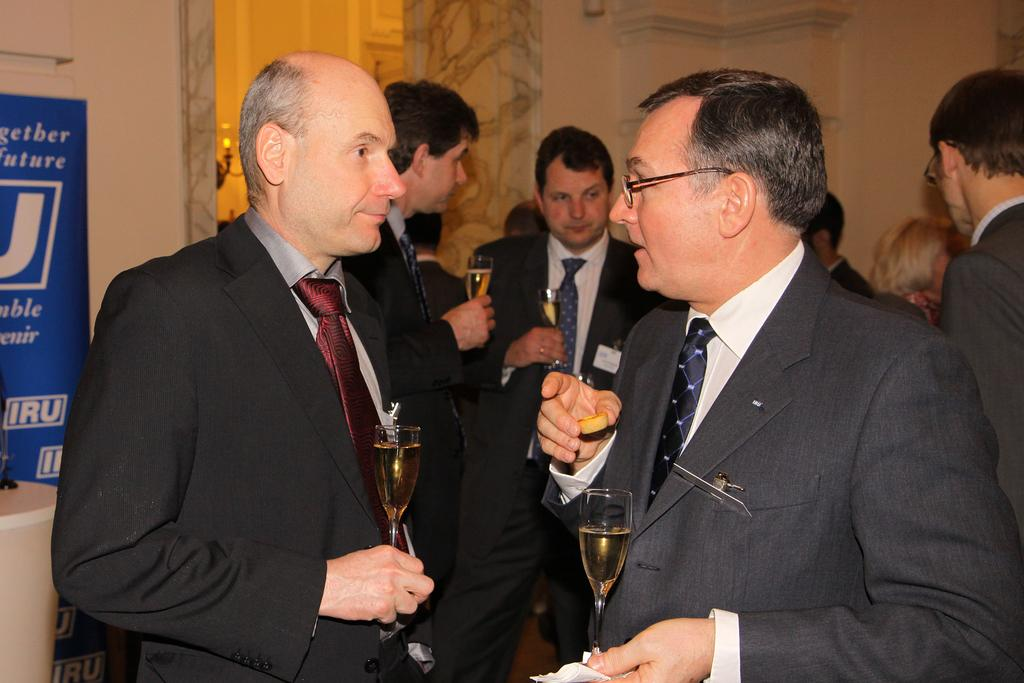How many people are in the image? There is a group of people in the image. What are the people doing in the image? The people are standing and holding glasses with drinks. What are the people wearing in the image? The people are wearing ties. What can be seen in the background of the image? There is a wall, a light, and a banner in the background of the image. What type of bit is being used by the people in the image? There is no bit present in the image; the people are holding glasses with drinks. What activity are the dolls participating in the image? There are no dolls present in the image. 